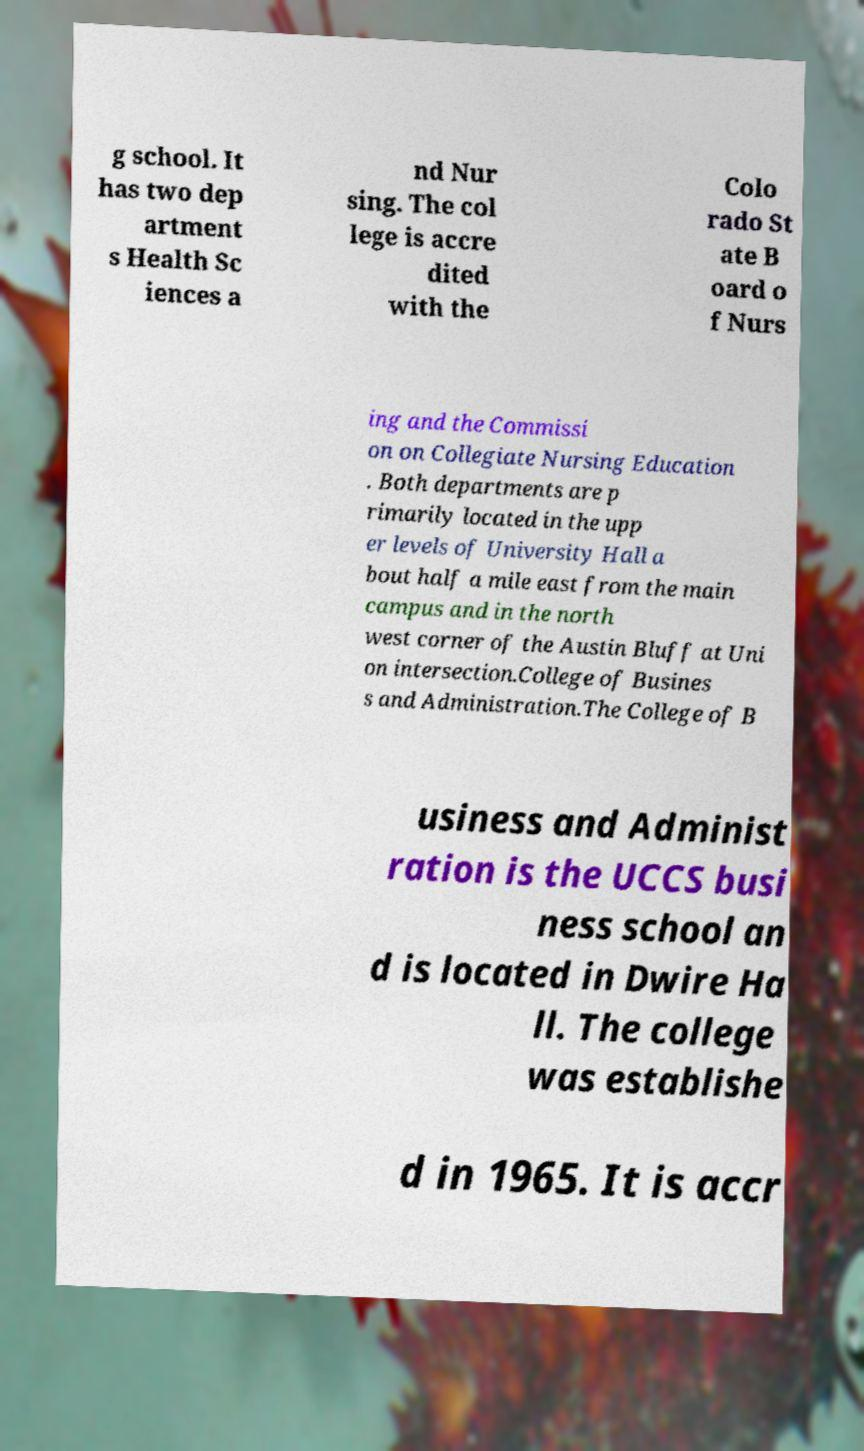Please identify and transcribe the text found in this image. g school. It has two dep artment s Health Sc iences a nd Nur sing. The col lege is accre dited with the Colo rado St ate B oard o f Nurs ing and the Commissi on on Collegiate Nursing Education . Both departments are p rimarily located in the upp er levels of University Hall a bout half a mile east from the main campus and in the north west corner of the Austin Bluff at Uni on intersection.College of Busines s and Administration.The College of B usiness and Administ ration is the UCCS busi ness school an d is located in Dwire Ha ll. The college was establishe d in 1965. It is accr 